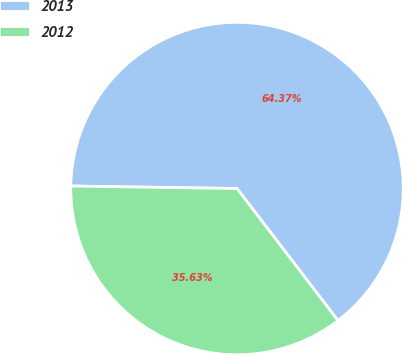Convert chart to OTSL. <chart><loc_0><loc_0><loc_500><loc_500><pie_chart><fcel>2013<fcel>2012<nl><fcel>64.37%<fcel>35.63%<nl></chart> 